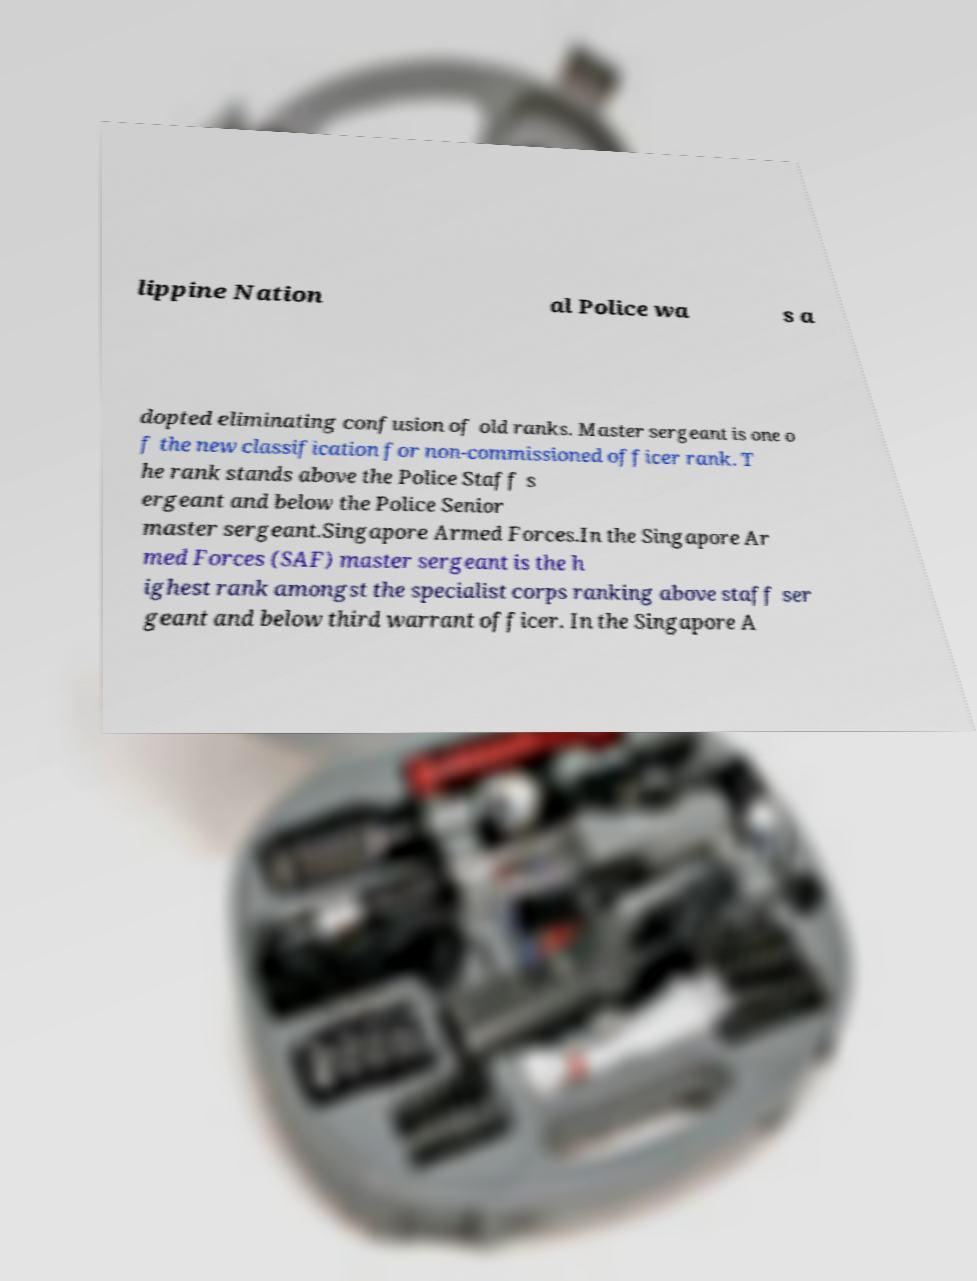There's text embedded in this image that I need extracted. Can you transcribe it verbatim? lippine Nation al Police wa s a dopted eliminating confusion of old ranks. Master sergeant is one o f the new classification for non-commissioned officer rank. T he rank stands above the Police Staff s ergeant and below the Police Senior master sergeant.Singapore Armed Forces.In the Singapore Ar med Forces (SAF) master sergeant is the h ighest rank amongst the specialist corps ranking above staff ser geant and below third warrant officer. In the Singapore A 